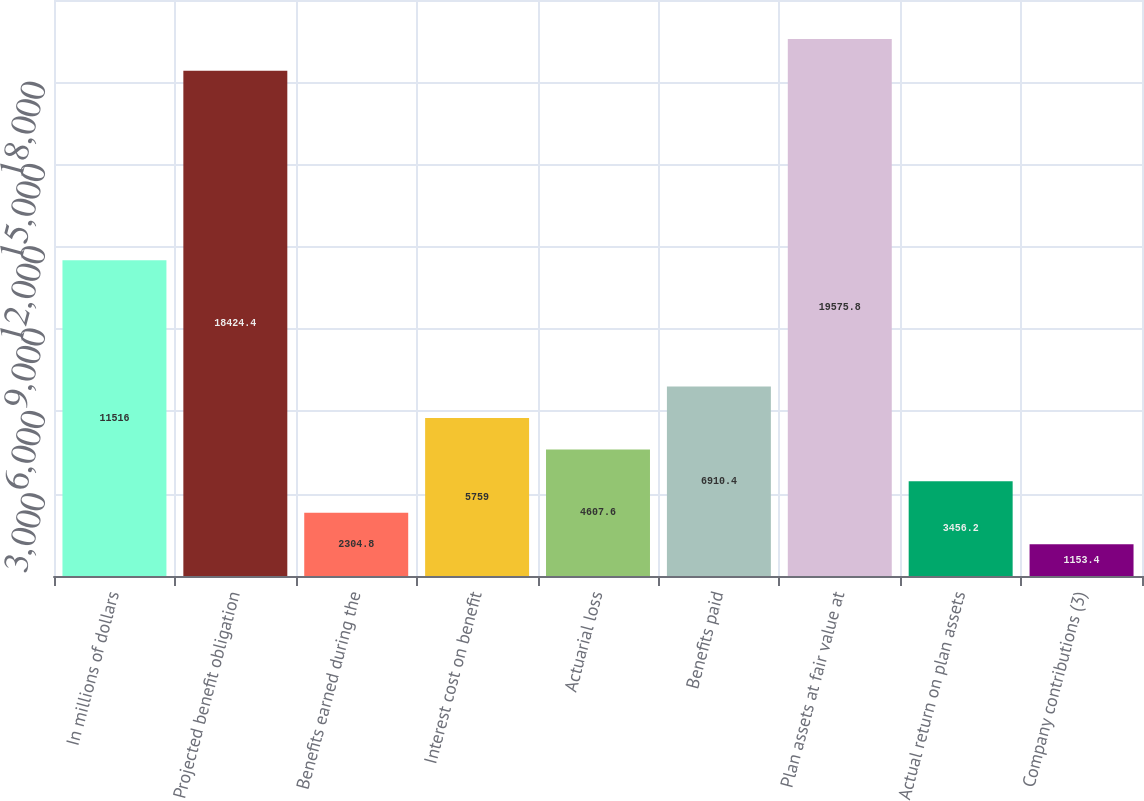Convert chart. <chart><loc_0><loc_0><loc_500><loc_500><bar_chart><fcel>In millions of dollars<fcel>Projected benefit obligation<fcel>Benefits earned during the<fcel>Interest cost on benefit<fcel>Actuarial loss<fcel>Benefits paid<fcel>Plan assets at fair value at<fcel>Actual return on plan assets<fcel>Company contributions (3)<nl><fcel>11516<fcel>18424.4<fcel>2304.8<fcel>5759<fcel>4607.6<fcel>6910.4<fcel>19575.8<fcel>3456.2<fcel>1153.4<nl></chart> 